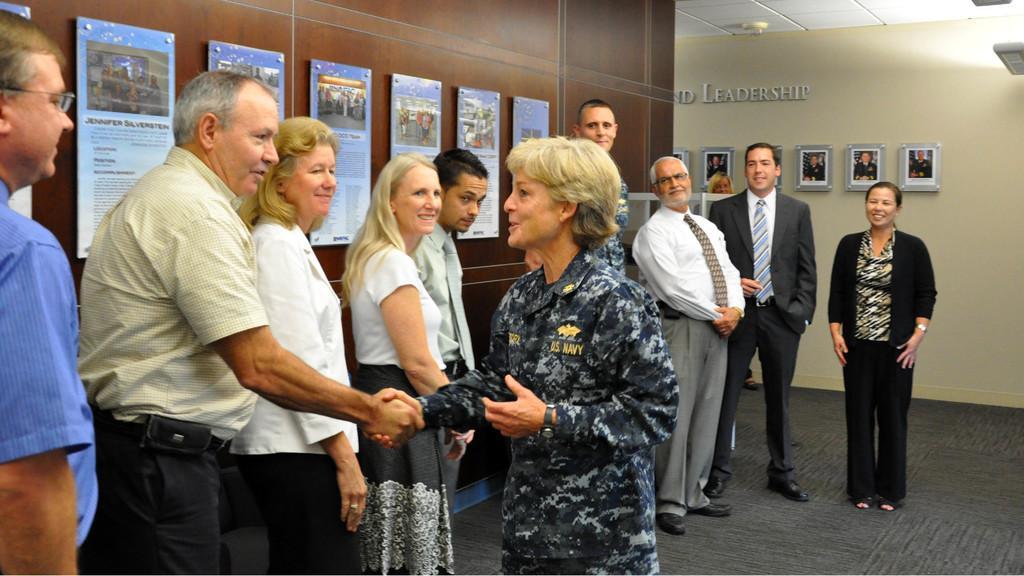Can you describe this image briefly? In this image there is an army personnel shaking hands with a few people standing in front of her, behind them there are a few posters on the wall, on the other side of the wall there are a few photo frames of different people, above them there is name. 